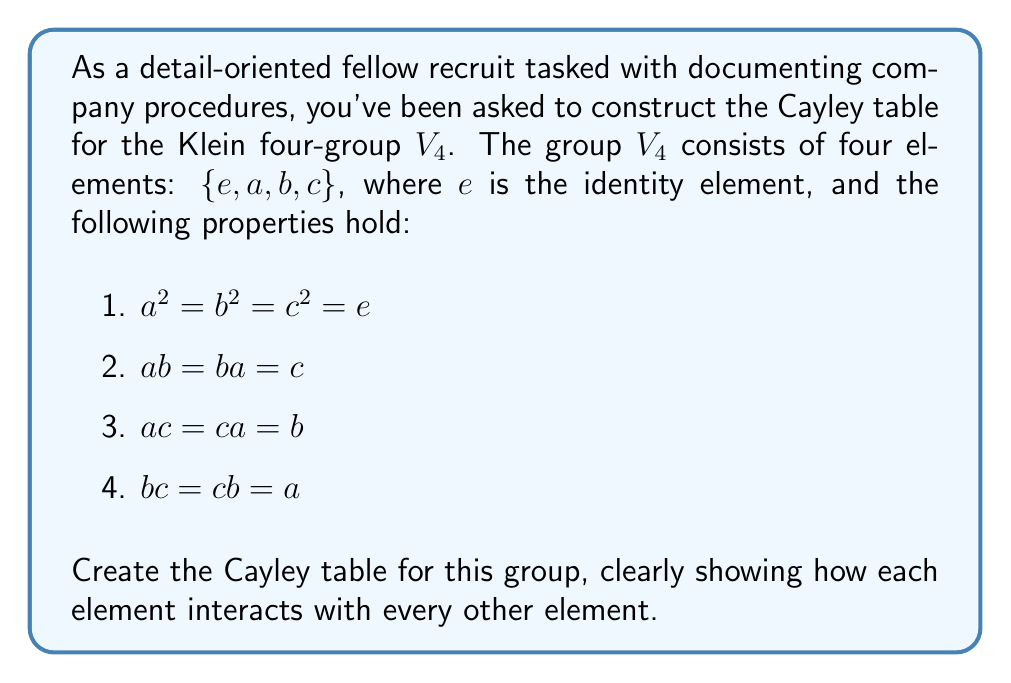Solve this math problem. To construct the Cayley table for the Klein four-group $V_4$, we'll follow these steps:

1. Set up the table:
   Create a 5x5 grid, with the group elements listed in both the first row and first column.

2. Fill in the identity element row and column:
   The identity element $e$ leaves all other elements unchanged, so the first row and first column will be identical to the header row and column.

3. Use the given properties to fill in the remaining cells:
   - $a^2 = b^2 = c^2 = e$
   - $ab = ba = c$
   - $ac = ca = b$
   - $bc = cb = a$

4. Double-check for consistency and closure:
   Ensure that every cell contains an element from the group and that the table is symmetric (since $V_4$ is abelian).

Let's fill in the table step by step:

$$
\begin{array}{c|cccc}
* & e & a & b & c \\
\hline
e & e & a & b & c \\
a & a & e & c & b \\
b & b & c & e & a \\
c & c & b & a & e
\end{array}
$$

Explanation of each row:
- Row $e$: $e * x = x$ for all $x \in V_4$
- Row $a$: $a * e = a$, $a * a = e$, $a * b = c$, $a * c = b$
- Row $b$: $b * e = b$, $b * a = c$, $b * b = e$, $b * c = a$
- Row $c$: $c * e = c$, $c * a = b$, $c * b = a$, $c * c = e$

We can verify that this table satisfies all the given properties and is consistent with the group axioms.
Answer: The Cayley table for the Klein four-group $V_4$ is:

$$
\begin{array}{c|cccc}
* & e & a & b & c \\
\hline
e & e & a & b & c \\
a & a & e & c & b \\
b & b & c & e & a \\
c & c & b & a & e
\end{array}
$$ 